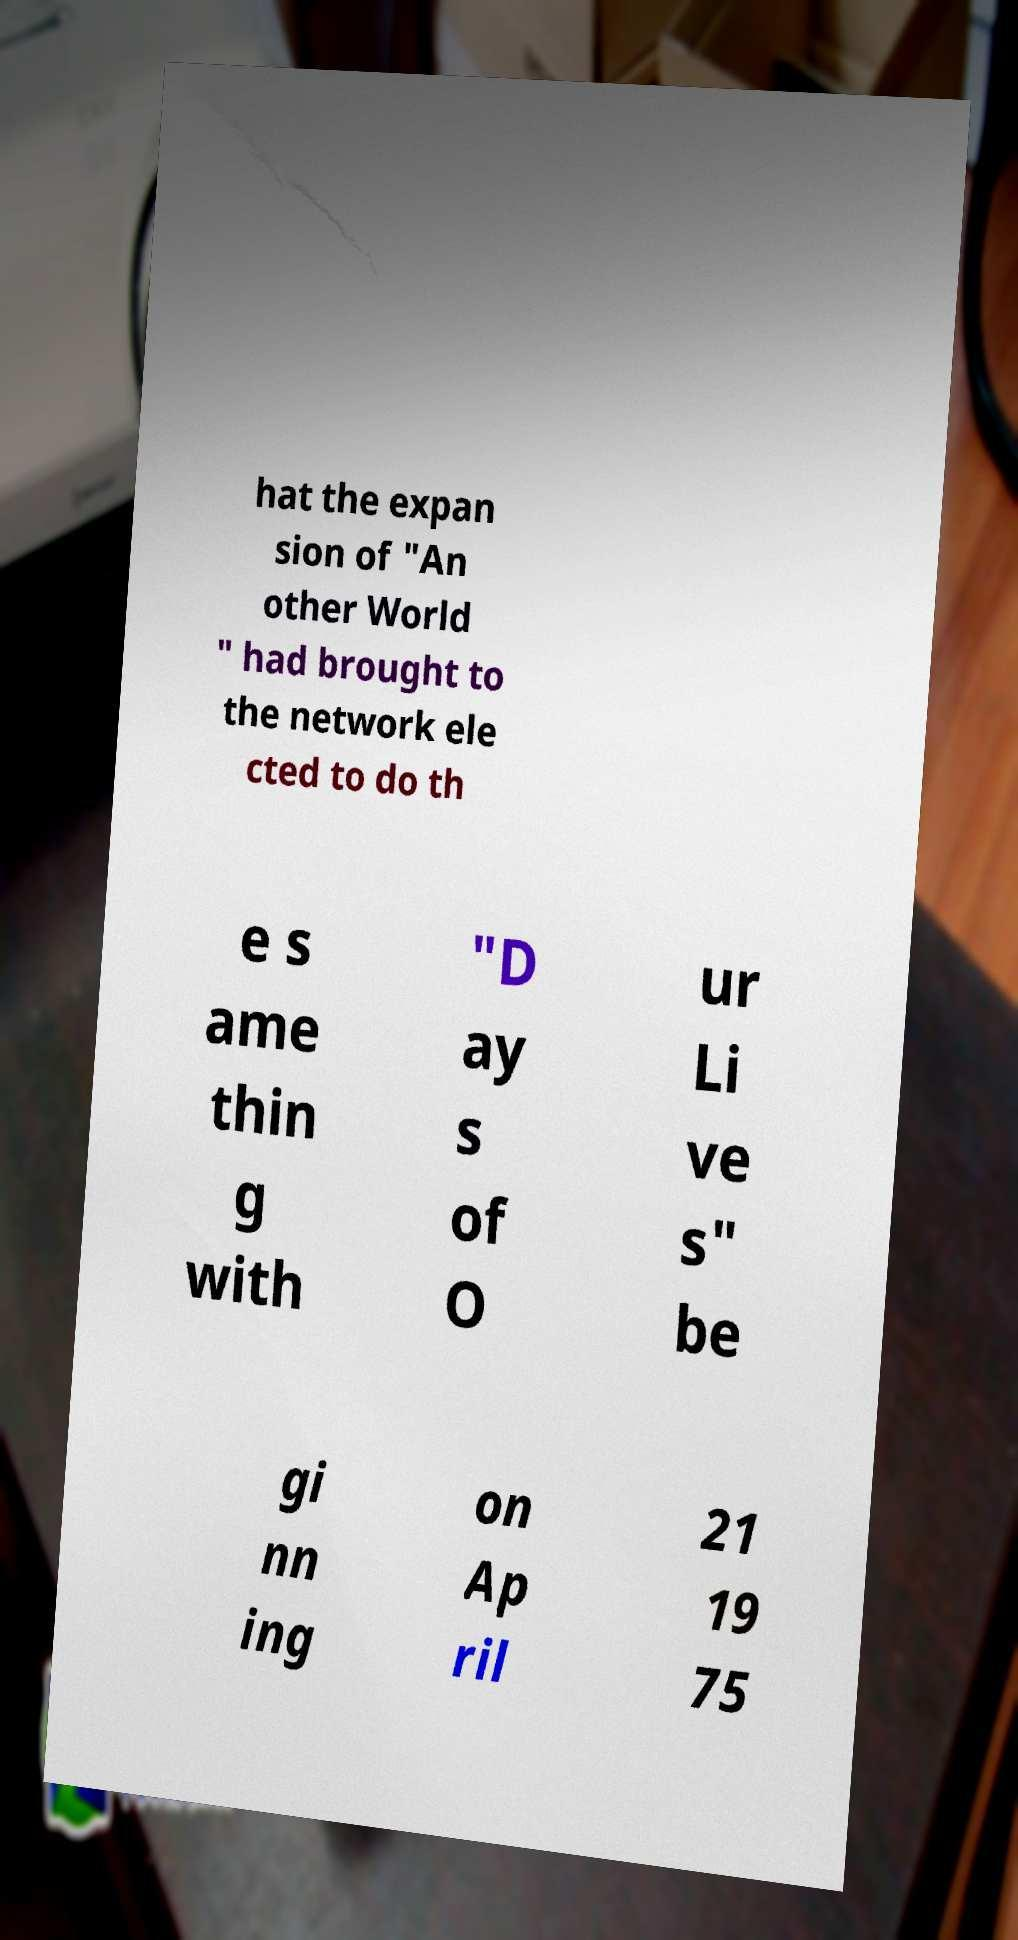Please read and relay the text visible in this image. What does it say? hat the expan sion of "An other World " had brought to the network ele cted to do th e s ame thin g with "D ay s of O ur Li ve s" be gi nn ing on Ap ril 21 19 75 